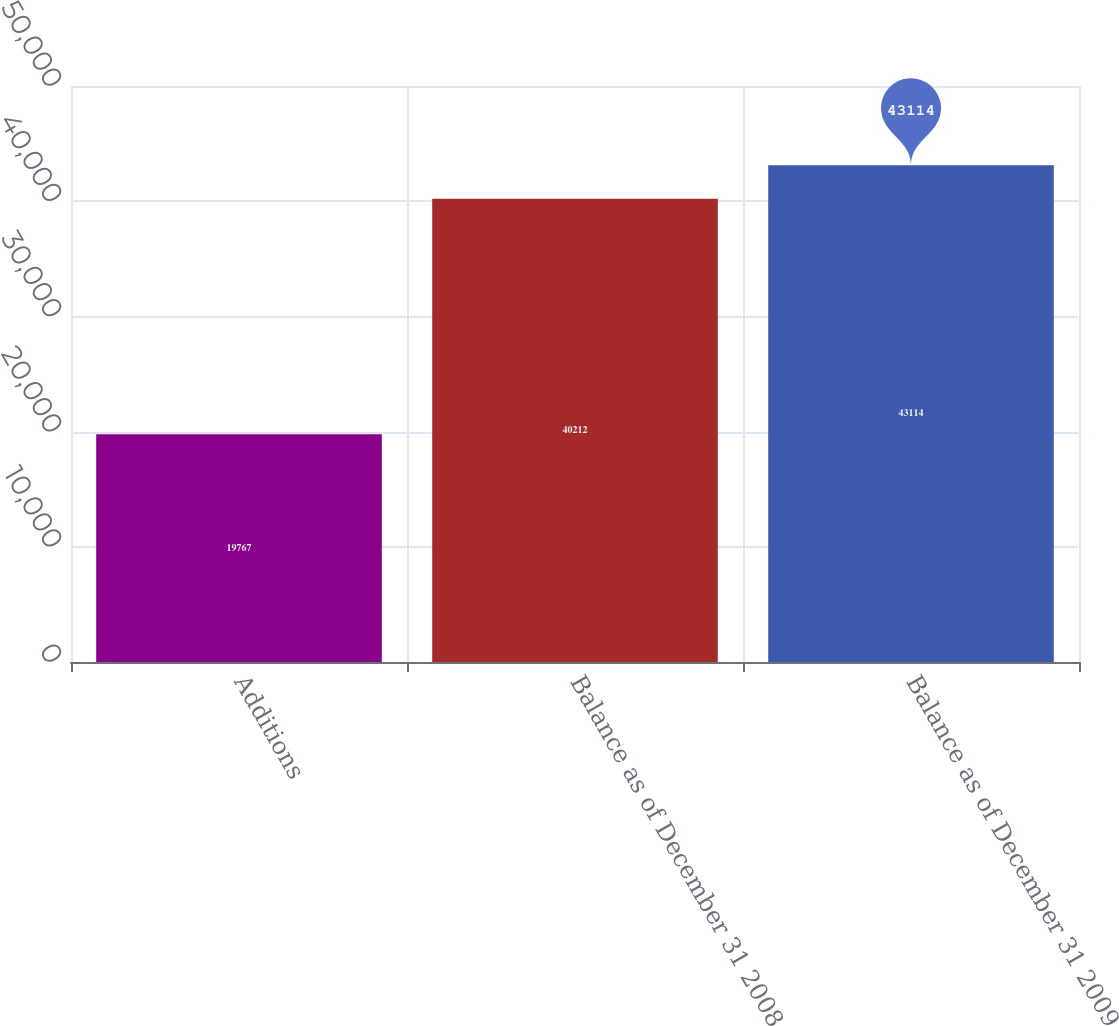<chart> <loc_0><loc_0><loc_500><loc_500><bar_chart><fcel>Additions<fcel>Balance as of December 31 2008<fcel>Balance as of December 31 2009<nl><fcel>19767<fcel>40212<fcel>43114<nl></chart> 